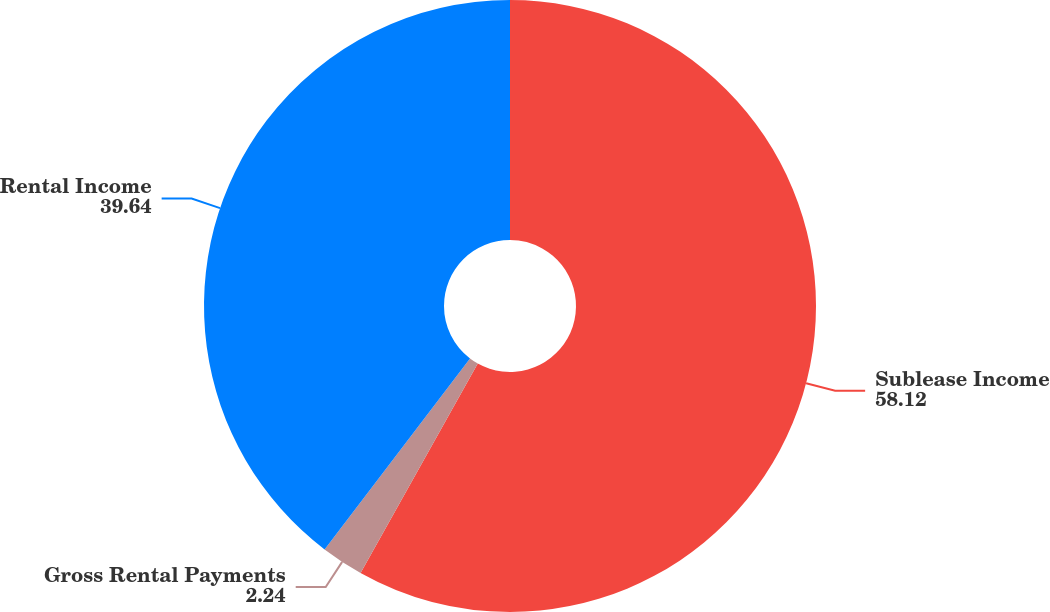Convert chart. <chart><loc_0><loc_0><loc_500><loc_500><pie_chart><fcel>Sublease Income<fcel>Gross Rental Payments<fcel>Rental Income<nl><fcel>58.12%<fcel>2.24%<fcel>39.64%<nl></chart> 